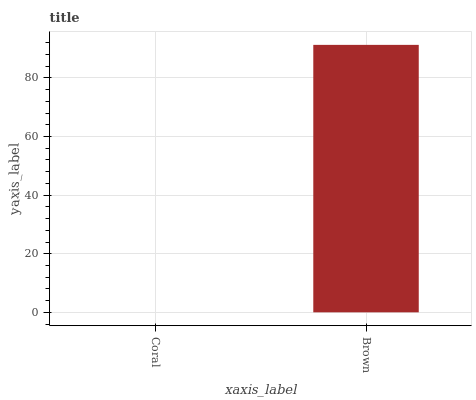Is Coral the minimum?
Answer yes or no. Yes. Is Brown the maximum?
Answer yes or no. Yes. Is Brown the minimum?
Answer yes or no. No. Is Brown greater than Coral?
Answer yes or no. Yes. Is Coral less than Brown?
Answer yes or no. Yes. Is Coral greater than Brown?
Answer yes or no. No. Is Brown less than Coral?
Answer yes or no. No. Is Brown the high median?
Answer yes or no. Yes. Is Coral the low median?
Answer yes or no. Yes. Is Coral the high median?
Answer yes or no. No. Is Brown the low median?
Answer yes or no. No. 